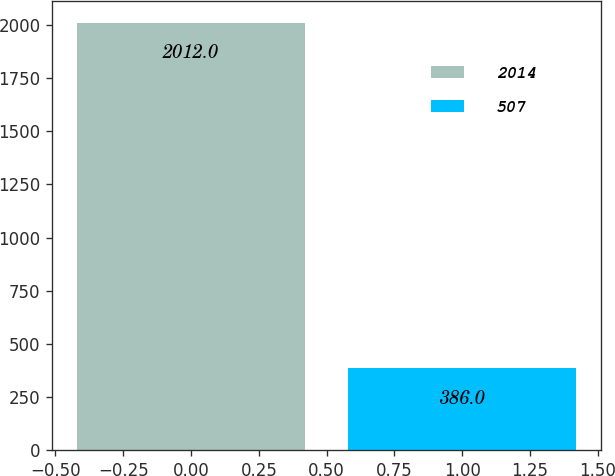Convert chart to OTSL. <chart><loc_0><loc_0><loc_500><loc_500><bar_chart><fcel>2014<fcel>507<nl><fcel>2012<fcel>386<nl></chart> 